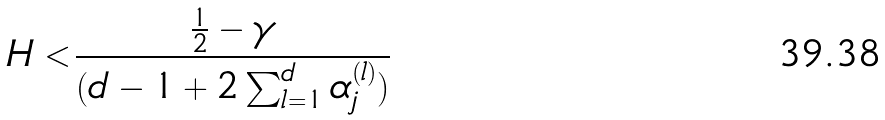<formula> <loc_0><loc_0><loc_500><loc_500>H < \frac { \frac { 1 } { 2 } - \gamma } { ( d - 1 + 2 \sum _ { l = 1 } ^ { d } \alpha _ { j } ^ { ( l ) } ) }</formula> 